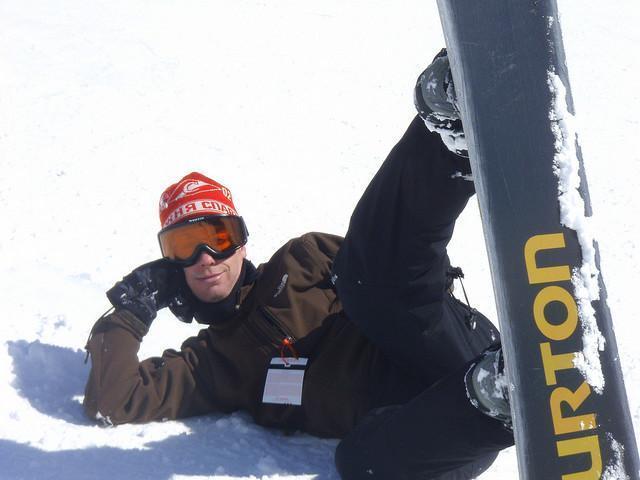How many sentient beings are dogs in this image?
Give a very brief answer. 0. 